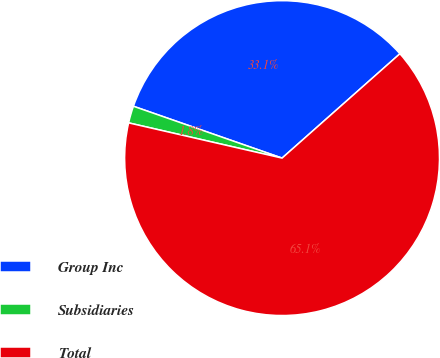Convert chart. <chart><loc_0><loc_0><loc_500><loc_500><pie_chart><fcel>Group Inc<fcel>Subsidiaries<fcel>Total<nl><fcel>33.12%<fcel>1.75%<fcel>65.12%<nl></chart> 